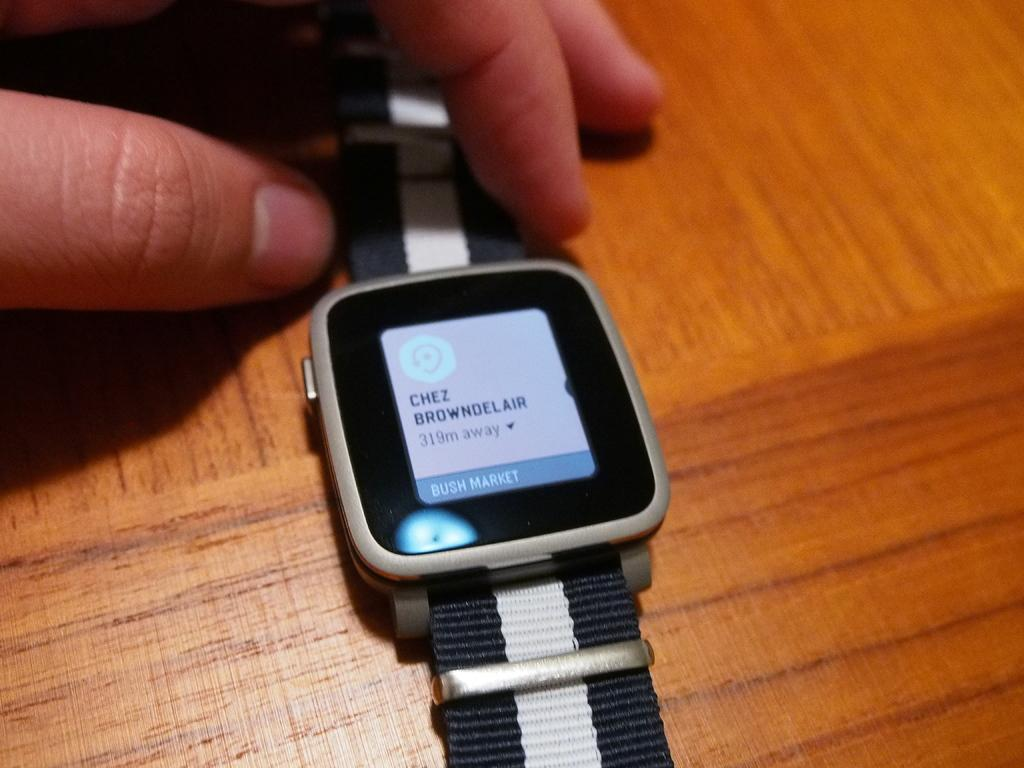<image>
Present a compact description of the photo's key features. Chez's name is on the screen of this smart phone. 